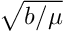<formula> <loc_0><loc_0><loc_500><loc_500>\sqrt { b / \mu }</formula> 